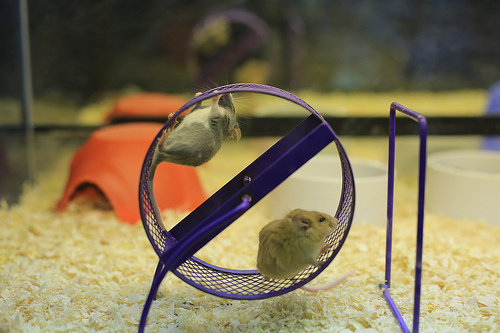<image>
Is there a mouse next to the rat? Yes. The mouse is positioned adjacent to the rat, located nearby in the same general area. 